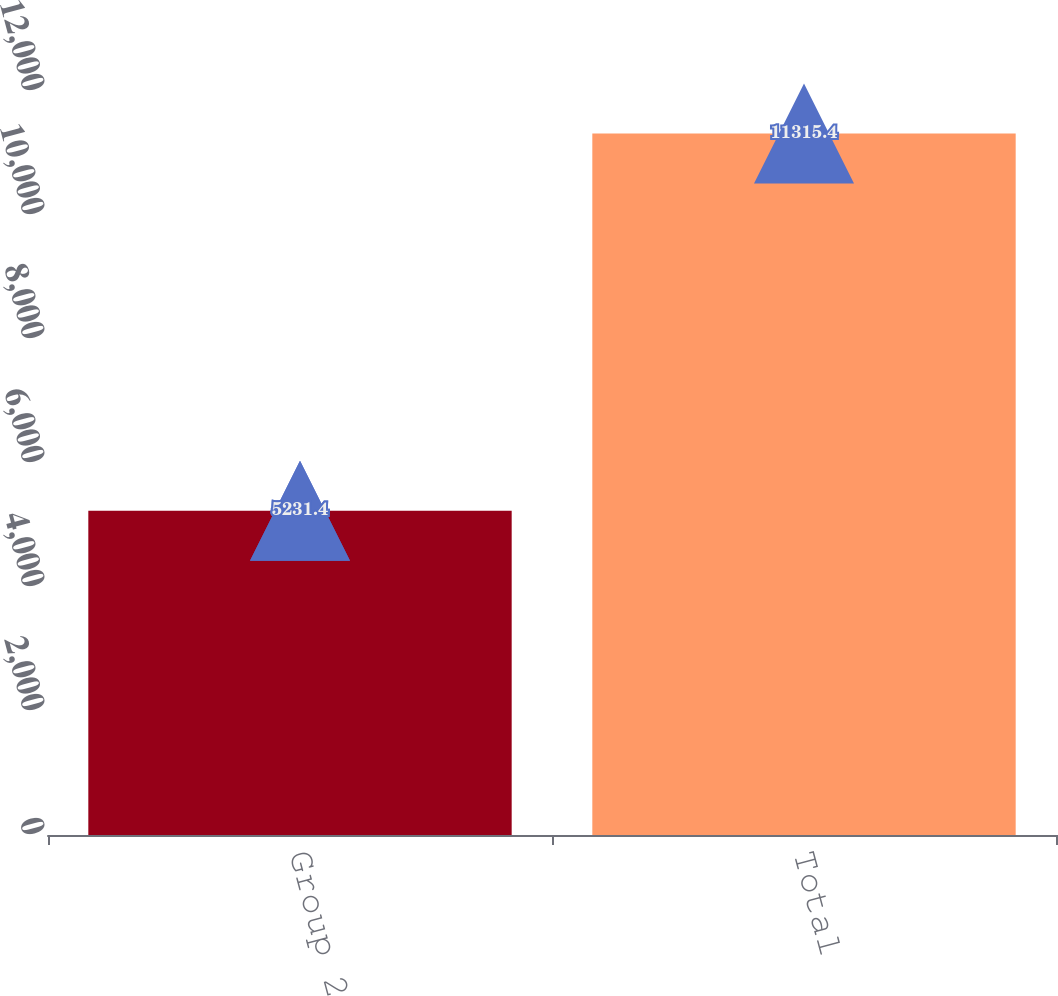Convert chart to OTSL. <chart><loc_0><loc_0><loc_500><loc_500><bar_chart><fcel>Group 2<fcel>Total<nl><fcel>5231.4<fcel>11315.4<nl></chart> 